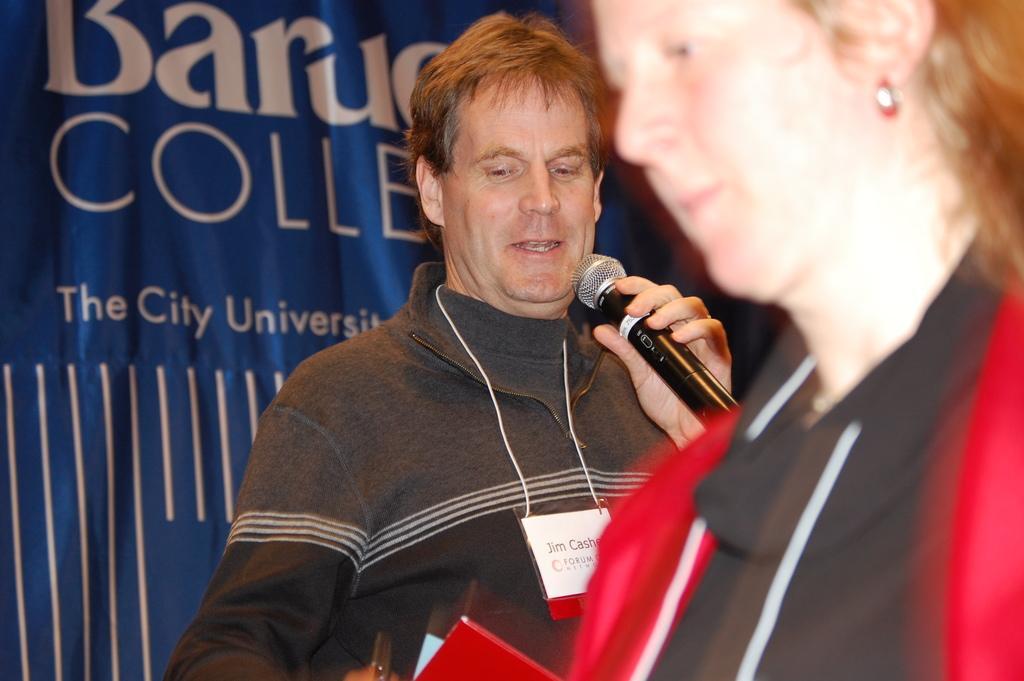Please provide a concise description of this image. This is the picture taken on a stage, the woman in black dress was standing behind the woman there is a man holding a microphone and explaining something. Background of these people is a banner which is in blue color. 